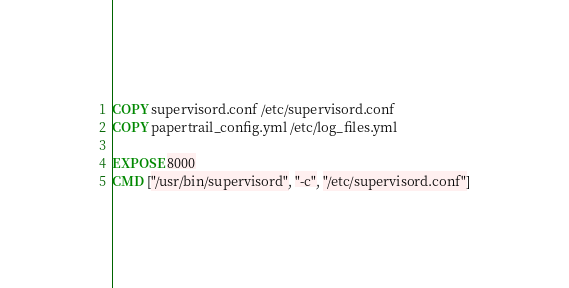Convert code to text. <code><loc_0><loc_0><loc_500><loc_500><_Dockerfile_>COPY supervisord.conf /etc/supervisord.conf
COPY papertrail_config.yml /etc/log_files.yml

EXPOSE 8000
CMD ["/usr/bin/supervisord", "-c", "/etc/supervisord.conf"]
</code> 